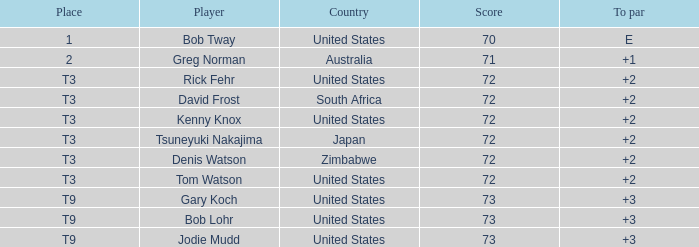Who obtained a score exceeding 72? Gary Koch, Bob Lohr, Jodie Mudd. 